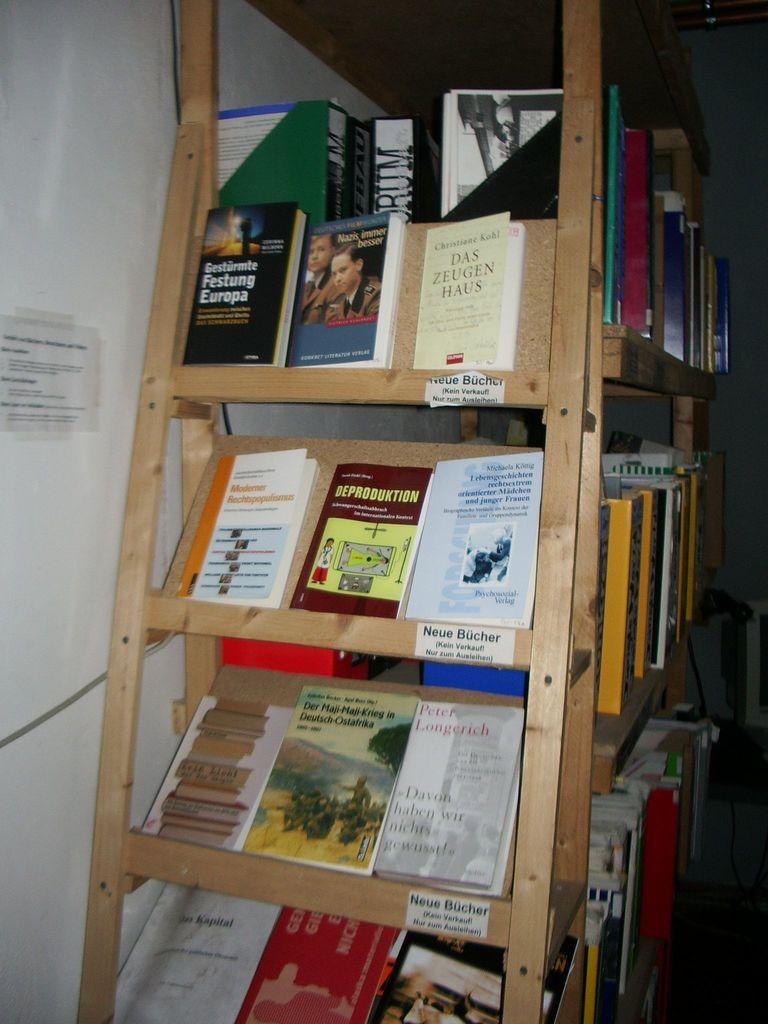What is the name of the book in the top left corner?
Offer a very short reply. Gesturmte festung europa. Name one of the books on the shelf?
Offer a very short reply. Das zeugen haus. 